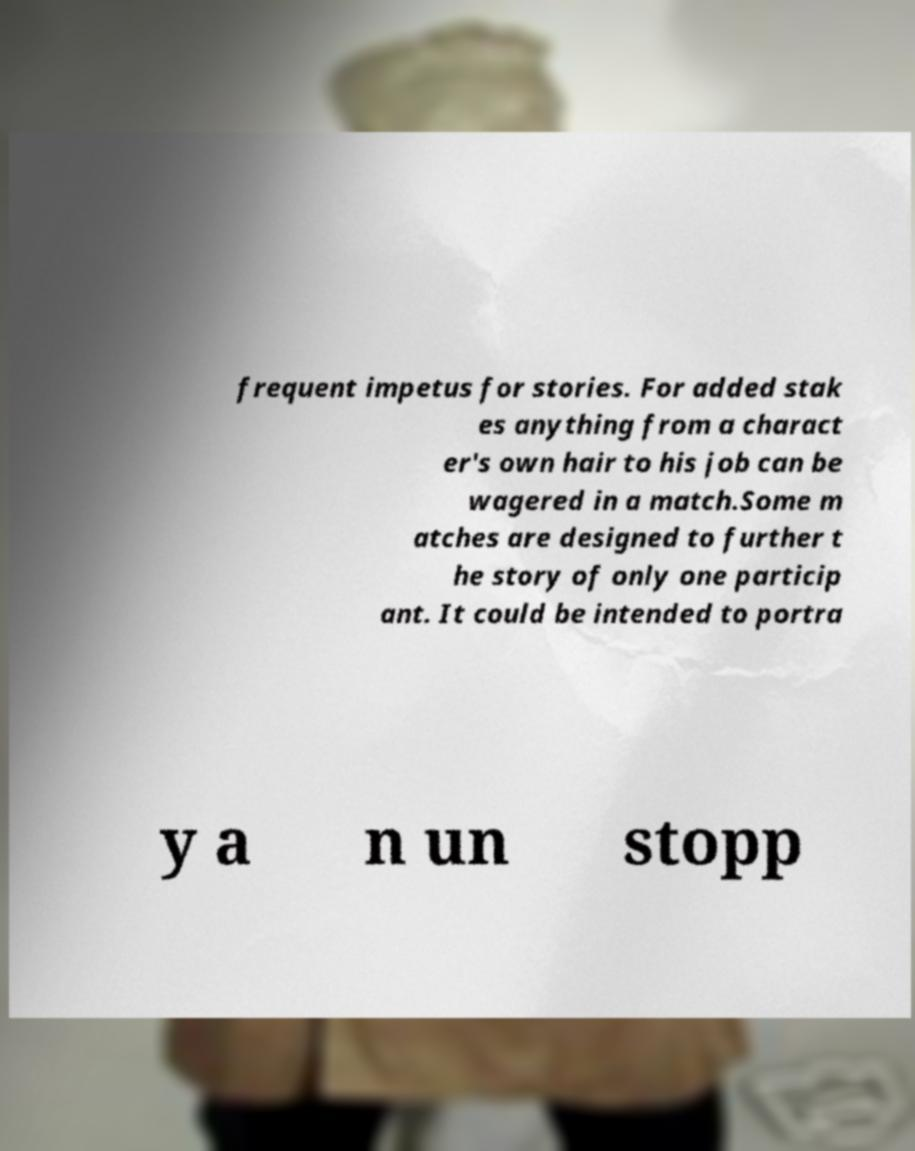Could you assist in decoding the text presented in this image and type it out clearly? frequent impetus for stories. For added stak es anything from a charact er's own hair to his job can be wagered in a match.Some m atches are designed to further t he story of only one particip ant. It could be intended to portra y a n un stopp 